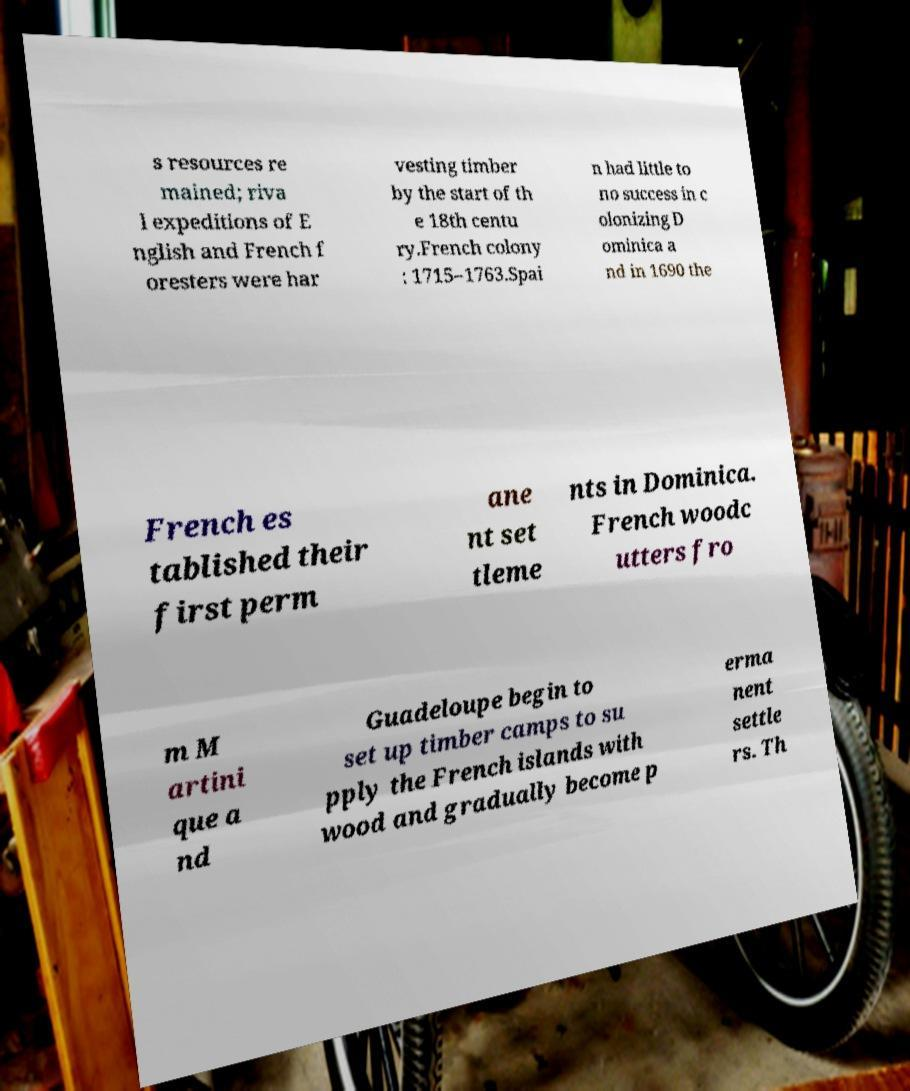Please identify and transcribe the text found in this image. s resources re mained; riva l expeditions of E nglish and French f oresters were har vesting timber by the start of th e 18th centu ry.French colony : 1715–1763.Spai n had little to no success in c olonizing D ominica a nd in 1690 the French es tablished their first perm ane nt set tleme nts in Dominica. French woodc utters fro m M artini que a nd Guadeloupe begin to set up timber camps to su pply the French islands with wood and gradually become p erma nent settle rs. Th 